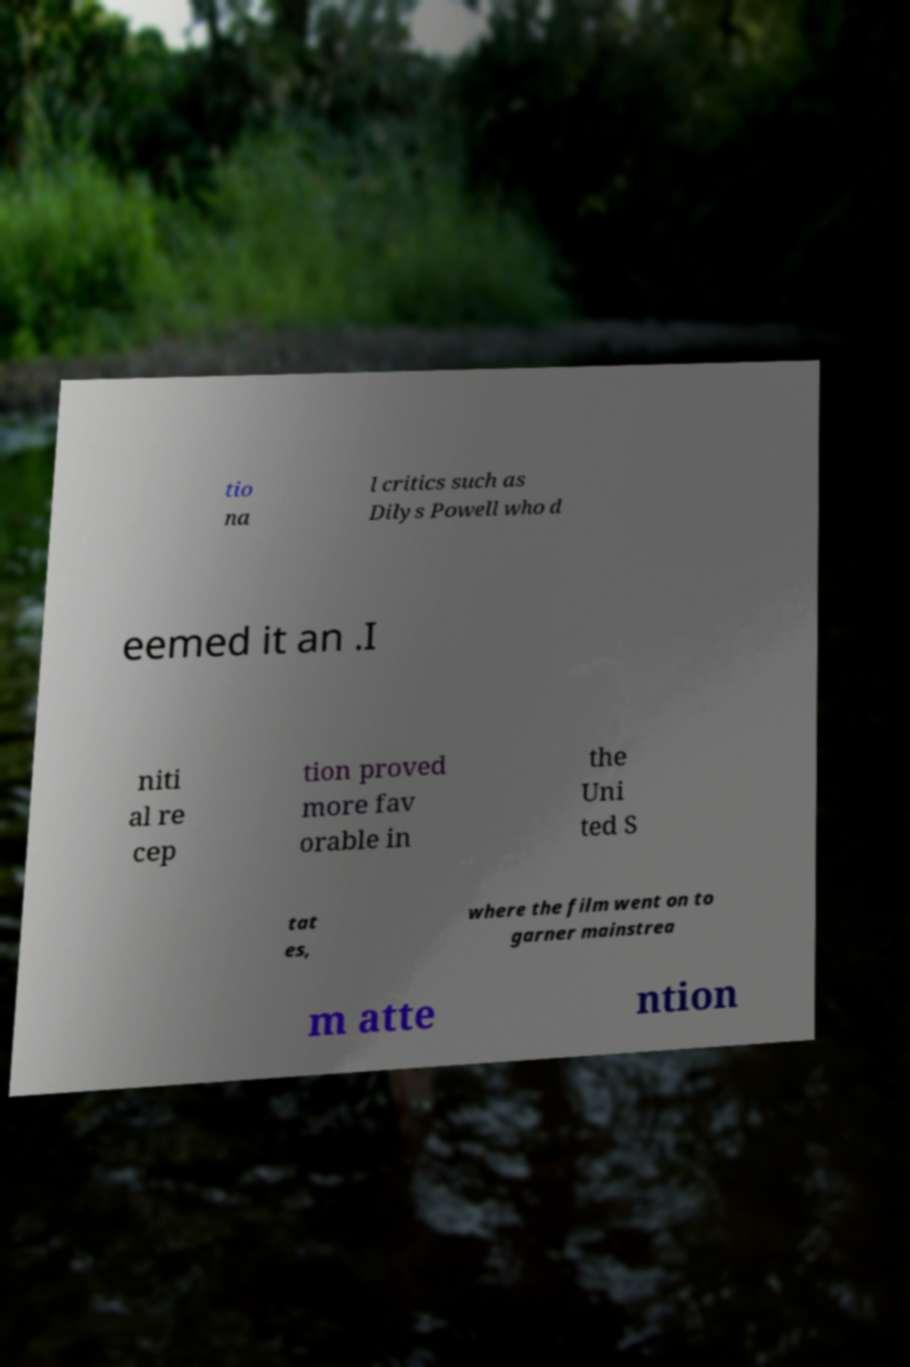Please read and relay the text visible in this image. What does it say? tio na l critics such as Dilys Powell who d eemed it an .I niti al re cep tion proved more fav orable in the Uni ted S tat es, where the film went on to garner mainstrea m atte ntion 